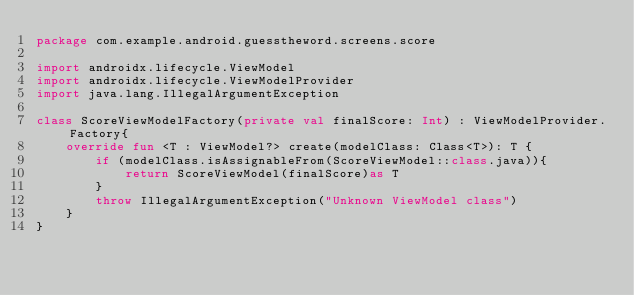<code> <loc_0><loc_0><loc_500><loc_500><_Kotlin_>package com.example.android.guesstheword.screens.score

import androidx.lifecycle.ViewModel
import androidx.lifecycle.ViewModelProvider
import java.lang.IllegalArgumentException

class ScoreViewModelFactory(private val finalScore: Int) : ViewModelProvider.Factory{
    override fun <T : ViewModel?> create(modelClass: Class<T>): T {
        if (modelClass.isAssignableFrom(ScoreViewModel::class.java)){
            return ScoreViewModel(finalScore)as T
        }
        throw IllegalArgumentException("Unknown ViewModel class")
    }
}

</code> 